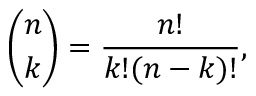<formula> <loc_0><loc_0><loc_500><loc_500>{ \binom { n } { k } } = { \frac { n ! } { k ! ( n - k ) ! } } ,</formula> 